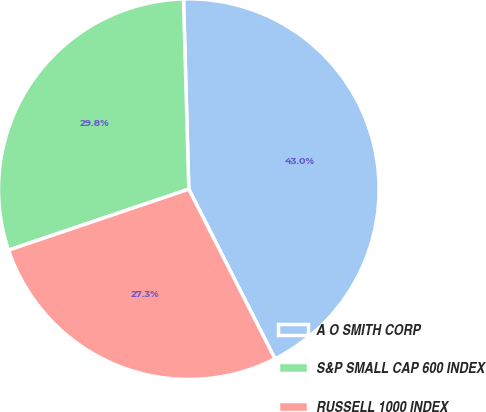Convert chart. <chart><loc_0><loc_0><loc_500><loc_500><pie_chart><fcel>A O SMITH CORP<fcel>S&P SMALL CAP 600 INDEX<fcel>RUSSELL 1000 INDEX<nl><fcel>42.96%<fcel>29.75%<fcel>27.29%<nl></chart> 